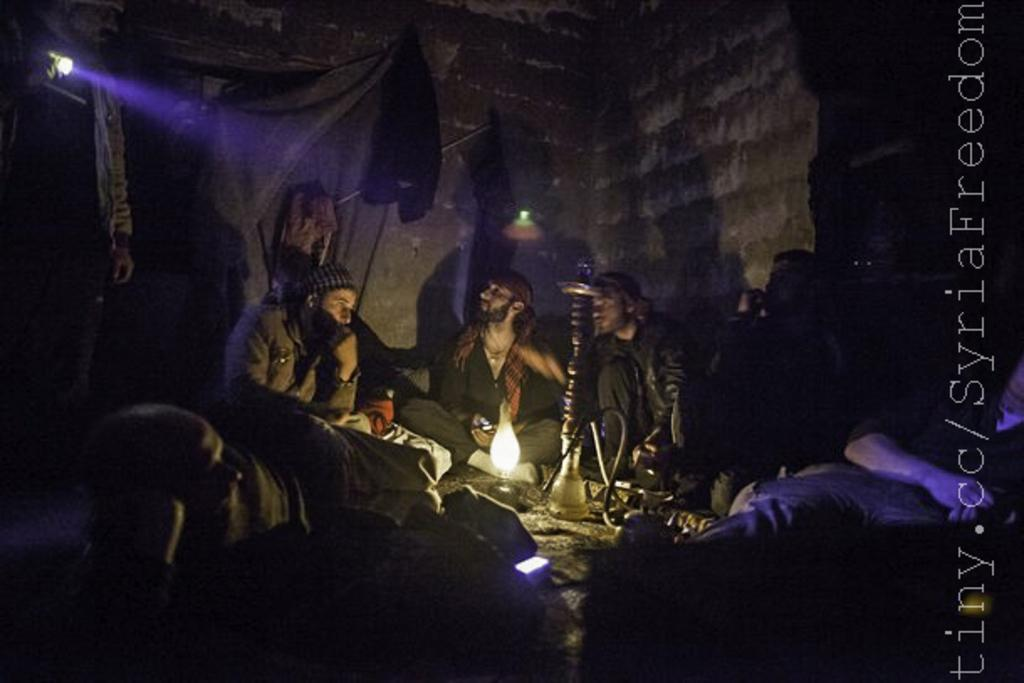What are the people in the image doing? There are persons sitting in the image. What object is in front of the persons? There is a lamp in front of the persons. What can be seen in the background of the image? There is a wall with a light in the background of the image. What type of car is parked around the curve in the image? There is no car or curve present in the image; it only features persons sitting and a lamp in front of them, as well as a wall with a light in the background. 